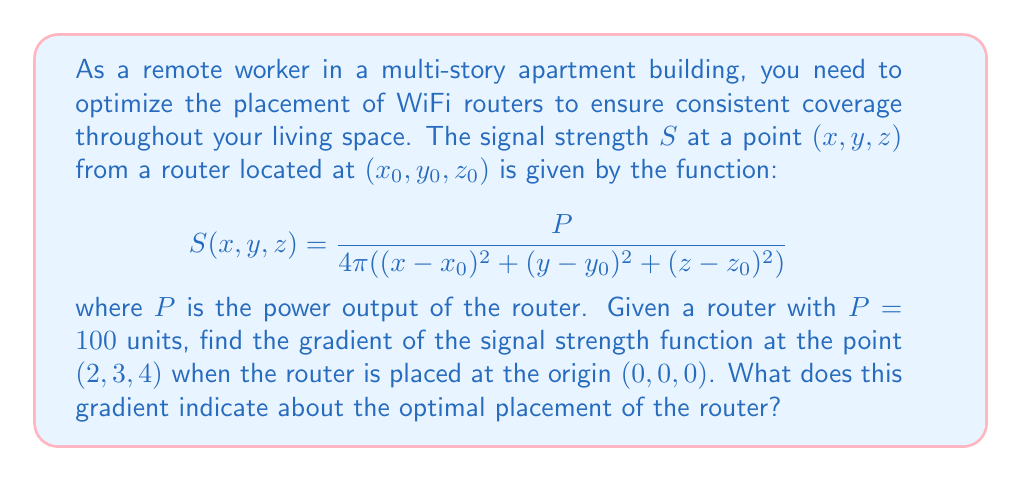Teach me how to tackle this problem. To solve this problem, we'll follow these steps:

1) First, we need to calculate the gradient of the signal strength function. The gradient is a vector of partial derivatives with respect to x, y, and z.

2) The general form of the gradient is:

   $$\nabla S = \left(\frac{\partial S}{\partial x}, \frac{\partial S}{\partial y}, \frac{\partial S}{\partial z}\right)$$

3) Let's calculate each partial derivative:

   $$\frac{\partial S}{\partial x} = \frac{-P}{4\pi} \cdot -2(x-x_0) \cdot ((x-x_0)^2 + (y-y_0)^2 + (z-z_0)^2)^{-2}$$
   $$\frac{\partial S}{\partial y} = \frac{-P}{4\pi} \cdot -2(y-y_0) \cdot ((x-x_0)^2 + (y-y_0)^2 + (z-z_0)^2)^{-2}$$
   $$\frac{\partial S}{\partial z} = \frac{-P}{4\pi} \cdot -2(z-z_0) \cdot ((x-x_0)^2 + (y-y_0)^2 + (z-z_0)^2)^{-2}$$

4) Now, we can substitute the given values: $P=100$, $(x_0,y_0,z_0)=(0,0,0)$, and $(x,y,z)=(2,3,4)$:

   $$\frac{\partial S}{\partial x} = \frac{100}{4\pi} \cdot \frac{2 \cdot 2}{(2^2 + 3^2 + 4^2)^2} = \frac{400}{4\pi(29)^2}$$
   $$\frac{\partial S}{\partial y} = \frac{100}{4\pi} \cdot \frac{2 \cdot 3}{(2^2 + 3^2 + 4^2)^2} = \frac{600}{4\pi(29)^2}$$
   $$\frac{\partial S}{\partial z} = \frac{100}{4\pi} \cdot \frac{2 \cdot 4}{(2^2 + 3^2 + 4^2)^2} = \frac{800}{4\pi(29)^2}$$

5) Therefore, the gradient at (2,3,4) is:

   $$\nabla S = \left(\frac{400}{4\pi(29)^2}, \frac{600}{4\pi(29)^2}, \frac{800}{4\pi(29)^2}\right)$$

6) This gradient points in the direction of steepest increase in signal strength. In this case, it points towards the origin (0,0,0) where the router is placed, as expected.

7) The magnitude of the gradient indicates how quickly the signal strength is changing. A larger magnitude suggests a steeper change in signal strength.

8) For optimal placement, we generally want to minimize the gradient's magnitude across the space to ensure more uniform coverage. This often involves placing routers at strategic points to balance the signal strength throughout the area.
Answer: $$\nabla S = \left(\frac{400}{4\pi(29)^2}, \frac{600}{4\pi(29)^2}, \frac{800}{4\pi(29)^2}\right)$$
The gradient points towards the router, indicating signal strength increases in that direction. For optimal placement, minimize gradient magnitude across the space. 